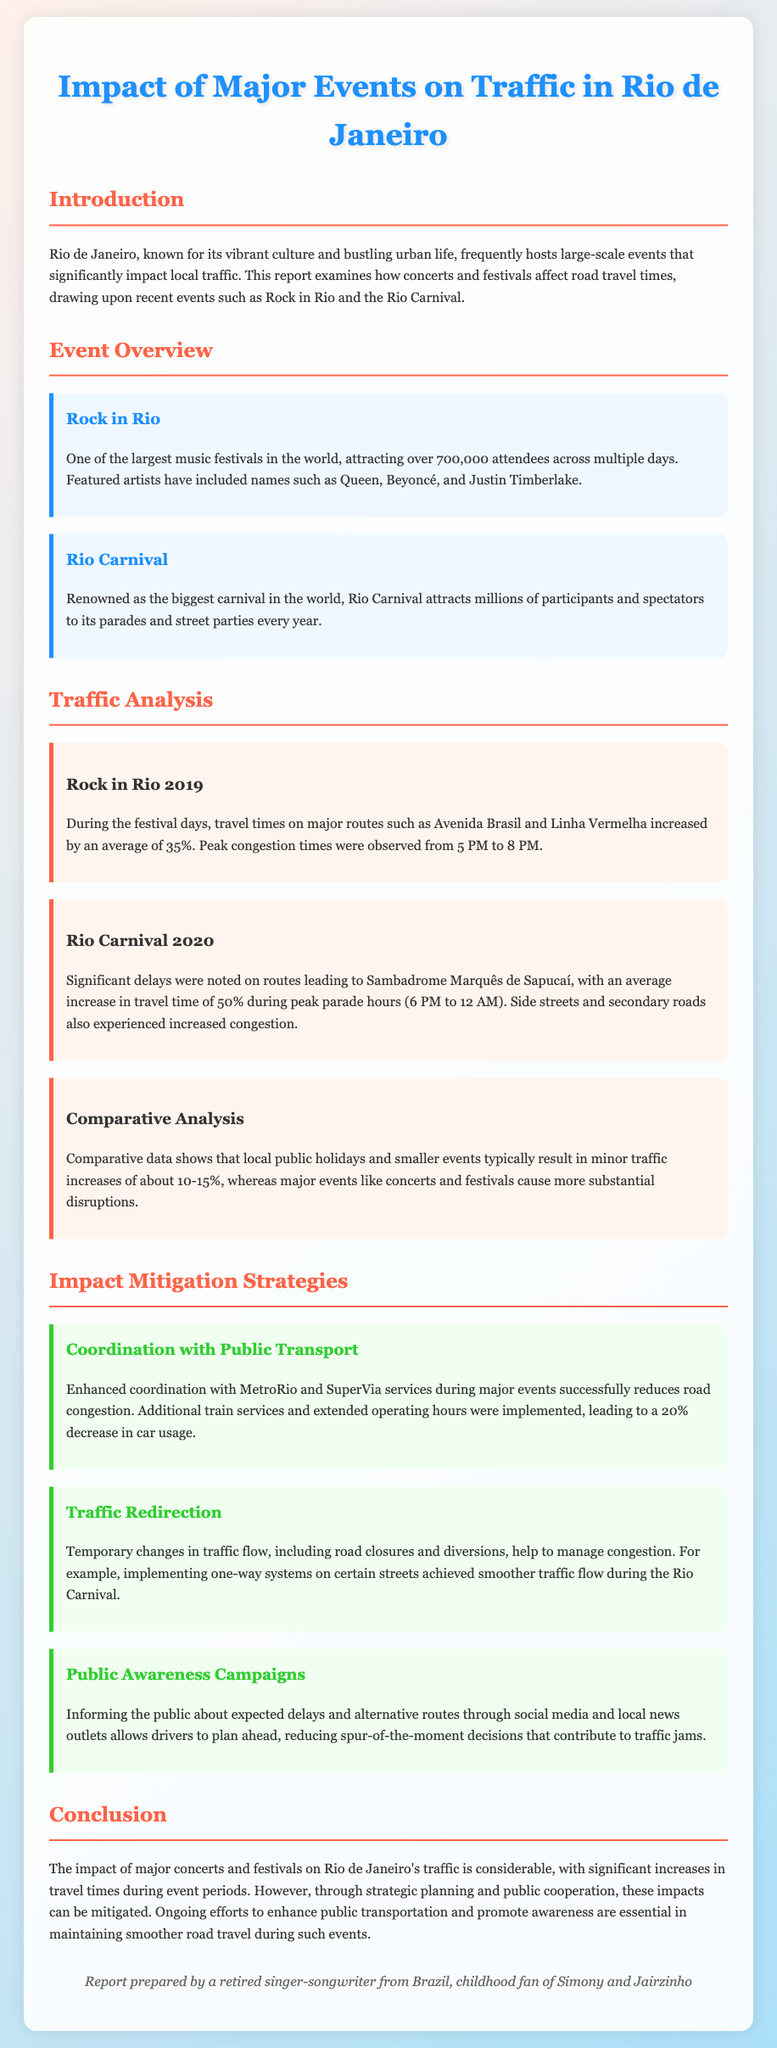What is the title of the report? The title of the report is prominently displayed at the top of the document, which is "Impact of Major Events on Traffic in Rio de Janeiro".
Answer: Impact of Major Events on Traffic in Rio de Janeiro What festival attracted over 700,000 attendees? The report states that Rock in Rio is one of the largest music festivals, attracting over 700,000 attendees.
Answer: Rock in Rio What was the average increase in travel time during Rock in Rio 2019? According to the traffic analysis, the average increase in travel time during Rock in Rio 2019 was 35%.
Answer: 35% What are the peak congestion times during Rio Carnival? The document specifies that the peak congestion times during Rio Carnival are from 6 PM to 12 AM.
Answer: 6 PM to 12 AM Which strategy led to a 20% decrease in car usage? The report mentions that enhanced coordination with MetroRio and SuperVia services during major events led to a 20% decrease in car usage.
Answer: Coordination with Public Transport What are the two major events discussed in the report? The report provides an overview of two significant events affecting traffic: Rock in Rio and Rio Carnival.
Answer: Rock in Rio and Rio Carnival What was the average increase in travel time for smaller events? The document states that smaller events typically result in minor traffic increases of about 10-15%.
Answer: 10-15% What is one of the impact mitigation strategies mentioned? The report discusses various strategies, one of which is Public Awareness Campaigns to inform the public about expected delays.
Answer: Public Awareness Campaigns 